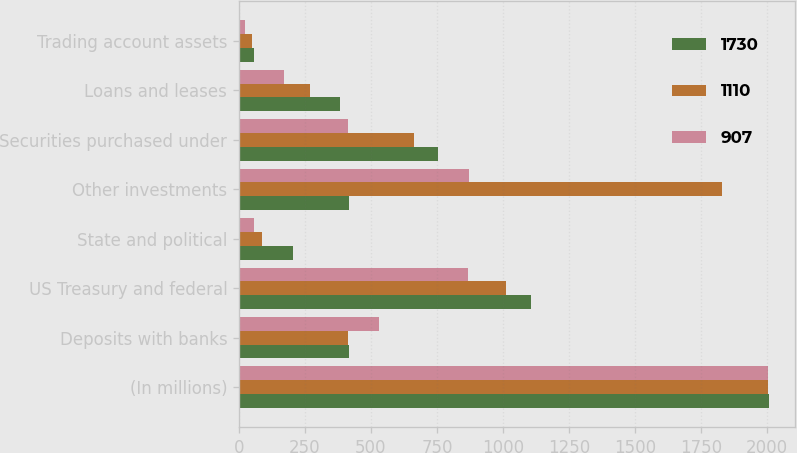Convert chart. <chart><loc_0><loc_0><loc_500><loc_500><stacked_bar_chart><ecel><fcel>(In millions)<fcel>Deposits with banks<fcel>US Treasury and federal<fcel>State and political<fcel>Other investments<fcel>Securities purchased under<fcel>Loans and leases<fcel>Trading account assets<nl><fcel>1730<fcel>2007<fcel>416<fcel>1106<fcel>205<fcel>416<fcel>756<fcel>382<fcel>55<nl><fcel>1110<fcel>2006<fcel>414<fcel>1011<fcel>88<fcel>1830<fcel>663<fcel>270<fcel>48<nl><fcel>907<fcel>2005<fcel>529<fcel>866<fcel>58<fcel>873<fcel>412<fcel>171<fcel>21<nl></chart> 